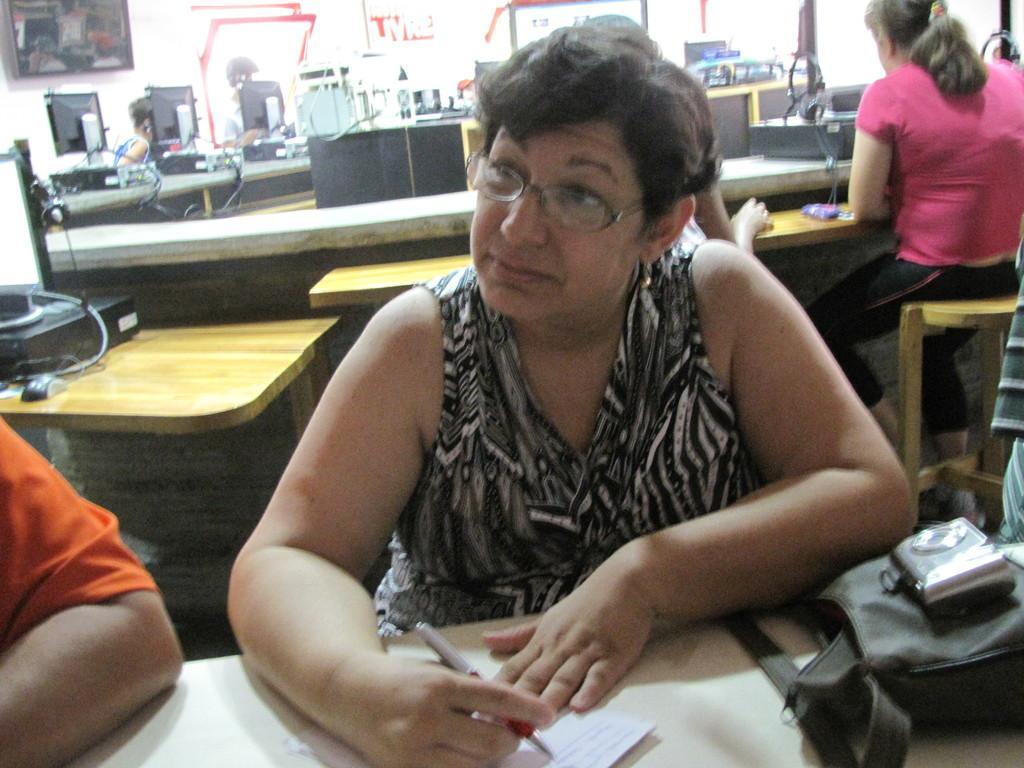In one or two sentences, can you explain what this image depicts? In the given image we can see that, there are any people sitting. this woman is holding a pen in her hand. This is a handbag. These are the systems. 